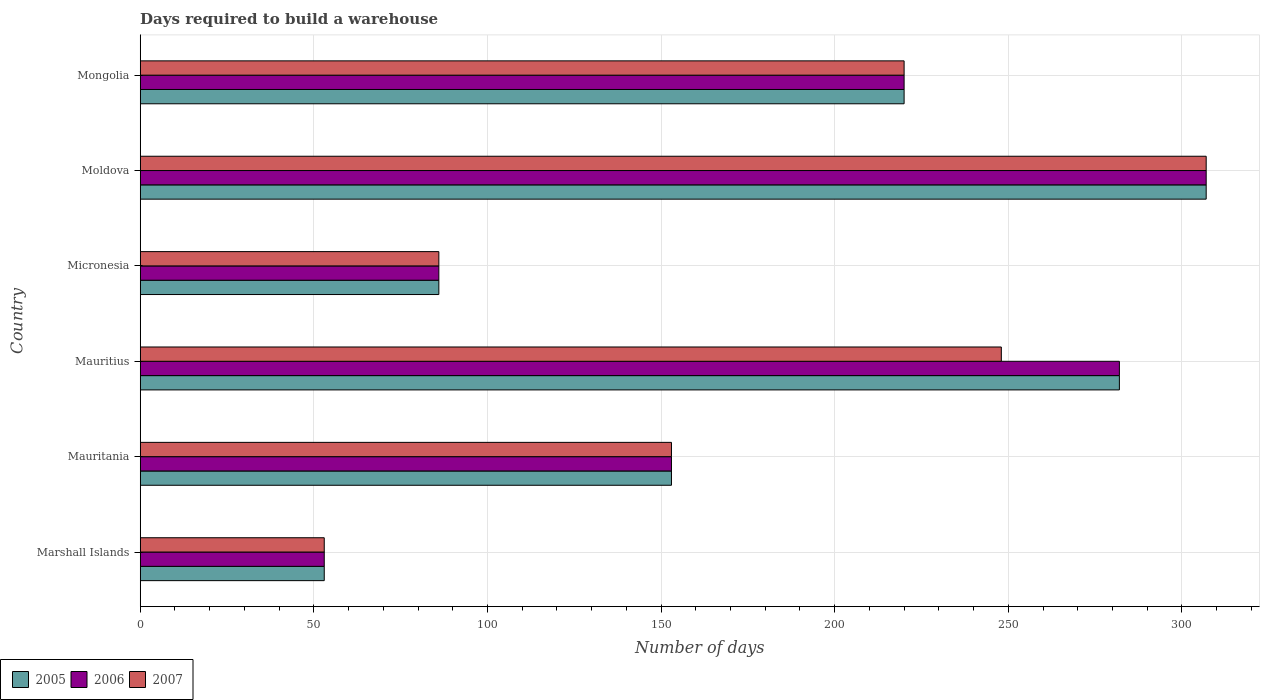How many bars are there on the 4th tick from the top?
Provide a succinct answer. 3. What is the label of the 1st group of bars from the top?
Give a very brief answer. Mongolia. In how many cases, is the number of bars for a given country not equal to the number of legend labels?
Keep it short and to the point. 0. What is the days required to build a warehouse in in 2007 in Mauritania?
Keep it short and to the point. 153. Across all countries, what is the maximum days required to build a warehouse in in 2006?
Provide a short and direct response. 307. In which country was the days required to build a warehouse in in 2006 maximum?
Provide a succinct answer. Moldova. In which country was the days required to build a warehouse in in 2006 minimum?
Keep it short and to the point. Marshall Islands. What is the total days required to build a warehouse in in 2007 in the graph?
Make the answer very short. 1067. What is the difference between the days required to build a warehouse in in 2006 in Mauritania and that in Moldova?
Provide a short and direct response. -154. What is the difference between the days required to build a warehouse in in 2005 in Marshall Islands and the days required to build a warehouse in in 2007 in Mongolia?
Your answer should be compact. -167. What is the average days required to build a warehouse in in 2005 per country?
Keep it short and to the point. 183.5. What is the difference between the days required to build a warehouse in in 2005 and days required to build a warehouse in in 2006 in Marshall Islands?
Make the answer very short. 0. What is the ratio of the days required to build a warehouse in in 2005 in Mauritius to that in Micronesia?
Offer a very short reply. 3.28. Is the days required to build a warehouse in in 2006 in Marshall Islands less than that in Mauritania?
Your response must be concise. Yes. Is the difference between the days required to build a warehouse in in 2005 in Micronesia and Mongolia greater than the difference between the days required to build a warehouse in in 2006 in Micronesia and Mongolia?
Your answer should be compact. No. What is the difference between the highest and the second highest days required to build a warehouse in in 2007?
Offer a very short reply. 59. What is the difference between the highest and the lowest days required to build a warehouse in in 2007?
Offer a terse response. 254. In how many countries, is the days required to build a warehouse in in 2006 greater than the average days required to build a warehouse in in 2006 taken over all countries?
Make the answer very short. 3. Is the sum of the days required to build a warehouse in in 2005 in Mauritania and Micronesia greater than the maximum days required to build a warehouse in in 2006 across all countries?
Make the answer very short. No. What does the 3rd bar from the bottom in Marshall Islands represents?
Your answer should be very brief. 2007. Is it the case that in every country, the sum of the days required to build a warehouse in in 2005 and days required to build a warehouse in in 2006 is greater than the days required to build a warehouse in in 2007?
Offer a very short reply. Yes. Are all the bars in the graph horizontal?
Provide a short and direct response. Yes. What is the difference between two consecutive major ticks on the X-axis?
Provide a short and direct response. 50. Are the values on the major ticks of X-axis written in scientific E-notation?
Give a very brief answer. No. Does the graph contain grids?
Keep it short and to the point. Yes. How many legend labels are there?
Provide a succinct answer. 3. What is the title of the graph?
Offer a terse response. Days required to build a warehouse. Does "1979" appear as one of the legend labels in the graph?
Give a very brief answer. No. What is the label or title of the X-axis?
Your answer should be compact. Number of days. What is the label or title of the Y-axis?
Provide a short and direct response. Country. What is the Number of days in 2006 in Marshall Islands?
Provide a short and direct response. 53. What is the Number of days in 2007 in Marshall Islands?
Provide a short and direct response. 53. What is the Number of days of 2005 in Mauritania?
Offer a terse response. 153. What is the Number of days of 2006 in Mauritania?
Ensure brevity in your answer.  153. What is the Number of days in 2007 in Mauritania?
Give a very brief answer. 153. What is the Number of days in 2005 in Mauritius?
Provide a succinct answer. 282. What is the Number of days in 2006 in Mauritius?
Your answer should be compact. 282. What is the Number of days in 2007 in Mauritius?
Your answer should be compact. 248. What is the Number of days in 2005 in Micronesia?
Offer a very short reply. 86. What is the Number of days of 2007 in Micronesia?
Your answer should be compact. 86. What is the Number of days in 2005 in Moldova?
Provide a succinct answer. 307. What is the Number of days in 2006 in Moldova?
Make the answer very short. 307. What is the Number of days in 2007 in Moldova?
Offer a terse response. 307. What is the Number of days of 2005 in Mongolia?
Your response must be concise. 220. What is the Number of days of 2006 in Mongolia?
Offer a very short reply. 220. What is the Number of days of 2007 in Mongolia?
Ensure brevity in your answer.  220. Across all countries, what is the maximum Number of days in 2005?
Your answer should be very brief. 307. Across all countries, what is the maximum Number of days in 2006?
Your response must be concise. 307. Across all countries, what is the maximum Number of days in 2007?
Give a very brief answer. 307. What is the total Number of days of 2005 in the graph?
Your answer should be very brief. 1101. What is the total Number of days of 2006 in the graph?
Ensure brevity in your answer.  1101. What is the total Number of days of 2007 in the graph?
Keep it short and to the point. 1067. What is the difference between the Number of days of 2005 in Marshall Islands and that in Mauritania?
Offer a very short reply. -100. What is the difference between the Number of days of 2006 in Marshall Islands and that in Mauritania?
Your answer should be very brief. -100. What is the difference between the Number of days of 2007 in Marshall Islands and that in Mauritania?
Keep it short and to the point. -100. What is the difference between the Number of days of 2005 in Marshall Islands and that in Mauritius?
Provide a succinct answer. -229. What is the difference between the Number of days in 2006 in Marshall Islands and that in Mauritius?
Make the answer very short. -229. What is the difference between the Number of days of 2007 in Marshall Islands and that in Mauritius?
Make the answer very short. -195. What is the difference between the Number of days in 2005 in Marshall Islands and that in Micronesia?
Your answer should be very brief. -33. What is the difference between the Number of days in 2006 in Marshall Islands and that in Micronesia?
Your answer should be compact. -33. What is the difference between the Number of days in 2007 in Marshall Islands and that in Micronesia?
Your answer should be compact. -33. What is the difference between the Number of days in 2005 in Marshall Islands and that in Moldova?
Offer a very short reply. -254. What is the difference between the Number of days of 2006 in Marshall Islands and that in Moldova?
Provide a short and direct response. -254. What is the difference between the Number of days of 2007 in Marshall Islands and that in Moldova?
Keep it short and to the point. -254. What is the difference between the Number of days of 2005 in Marshall Islands and that in Mongolia?
Offer a terse response. -167. What is the difference between the Number of days in 2006 in Marshall Islands and that in Mongolia?
Offer a very short reply. -167. What is the difference between the Number of days in 2007 in Marshall Islands and that in Mongolia?
Keep it short and to the point. -167. What is the difference between the Number of days of 2005 in Mauritania and that in Mauritius?
Your response must be concise. -129. What is the difference between the Number of days of 2006 in Mauritania and that in Mauritius?
Provide a short and direct response. -129. What is the difference between the Number of days in 2007 in Mauritania and that in Mauritius?
Offer a very short reply. -95. What is the difference between the Number of days in 2005 in Mauritania and that in Micronesia?
Offer a very short reply. 67. What is the difference between the Number of days in 2007 in Mauritania and that in Micronesia?
Offer a terse response. 67. What is the difference between the Number of days of 2005 in Mauritania and that in Moldova?
Your answer should be very brief. -154. What is the difference between the Number of days of 2006 in Mauritania and that in Moldova?
Ensure brevity in your answer.  -154. What is the difference between the Number of days of 2007 in Mauritania and that in Moldova?
Make the answer very short. -154. What is the difference between the Number of days in 2005 in Mauritania and that in Mongolia?
Keep it short and to the point. -67. What is the difference between the Number of days of 2006 in Mauritania and that in Mongolia?
Keep it short and to the point. -67. What is the difference between the Number of days of 2007 in Mauritania and that in Mongolia?
Your answer should be very brief. -67. What is the difference between the Number of days of 2005 in Mauritius and that in Micronesia?
Provide a succinct answer. 196. What is the difference between the Number of days in 2006 in Mauritius and that in Micronesia?
Provide a succinct answer. 196. What is the difference between the Number of days of 2007 in Mauritius and that in Micronesia?
Your answer should be compact. 162. What is the difference between the Number of days of 2007 in Mauritius and that in Moldova?
Offer a terse response. -59. What is the difference between the Number of days in 2007 in Mauritius and that in Mongolia?
Your answer should be very brief. 28. What is the difference between the Number of days of 2005 in Micronesia and that in Moldova?
Make the answer very short. -221. What is the difference between the Number of days of 2006 in Micronesia and that in Moldova?
Ensure brevity in your answer.  -221. What is the difference between the Number of days in 2007 in Micronesia and that in Moldova?
Your answer should be very brief. -221. What is the difference between the Number of days in 2005 in Micronesia and that in Mongolia?
Your response must be concise. -134. What is the difference between the Number of days of 2006 in Micronesia and that in Mongolia?
Offer a terse response. -134. What is the difference between the Number of days of 2007 in Micronesia and that in Mongolia?
Provide a short and direct response. -134. What is the difference between the Number of days in 2005 in Moldova and that in Mongolia?
Make the answer very short. 87. What is the difference between the Number of days in 2005 in Marshall Islands and the Number of days in 2006 in Mauritania?
Provide a short and direct response. -100. What is the difference between the Number of days in 2005 in Marshall Islands and the Number of days in 2007 in Mauritania?
Provide a succinct answer. -100. What is the difference between the Number of days of 2006 in Marshall Islands and the Number of days of 2007 in Mauritania?
Your response must be concise. -100. What is the difference between the Number of days in 2005 in Marshall Islands and the Number of days in 2006 in Mauritius?
Make the answer very short. -229. What is the difference between the Number of days in 2005 in Marshall Islands and the Number of days in 2007 in Mauritius?
Ensure brevity in your answer.  -195. What is the difference between the Number of days in 2006 in Marshall Islands and the Number of days in 2007 in Mauritius?
Keep it short and to the point. -195. What is the difference between the Number of days in 2005 in Marshall Islands and the Number of days in 2006 in Micronesia?
Provide a short and direct response. -33. What is the difference between the Number of days in 2005 in Marshall Islands and the Number of days in 2007 in Micronesia?
Ensure brevity in your answer.  -33. What is the difference between the Number of days of 2006 in Marshall Islands and the Number of days of 2007 in Micronesia?
Keep it short and to the point. -33. What is the difference between the Number of days in 2005 in Marshall Islands and the Number of days in 2006 in Moldova?
Provide a succinct answer. -254. What is the difference between the Number of days in 2005 in Marshall Islands and the Number of days in 2007 in Moldova?
Your answer should be very brief. -254. What is the difference between the Number of days of 2006 in Marshall Islands and the Number of days of 2007 in Moldova?
Provide a succinct answer. -254. What is the difference between the Number of days of 2005 in Marshall Islands and the Number of days of 2006 in Mongolia?
Your answer should be compact. -167. What is the difference between the Number of days in 2005 in Marshall Islands and the Number of days in 2007 in Mongolia?
Provide a short and direct response. -167. What is the difference between the Number of days in 2006 in Marshall Islands and the Number of days in 2007 in Mongolia?
Offer a terse response. -167. What is the difference between the Number of days in 2005 in Mauritania and the Number of days in 2006 in Mauritius?
Provide a short and direct response. -129. What is the difference between the Number of days in 2005 in Mauritania and the Number of days in 2007 in Mauritius?
Your answer should be compact. -95. What is the difference between the Number of days in 2006 in Mauritania and the Number of days in 2007 in Mauritius?
Give a very brief answer. -95. What is the difference between the Number of days of 2005 in Mauritania and the Number of days of 2006 in Micronesia?
Ensure brevity in your answer.  67. What is the difference between the Number of days in 2005 in Mauritania and the Number of days in 2007 in Micronesia?
Ensure brevity in your answer.  67. What is the difference between the Number of days of 2005 in Mauritania and the Number of days of 2006 in Moldova?
Your answer should be very brief. -154. What is the difference between the Number of days in 2005 in Mauritania and the Number of days in 2007 in Moldova?
Give a very brief answer. -154. What is the difference between the Number of days in 2006 in Mauritania and the Number of days in 2007 in Moldova?
Offer a terse response. -154. What is the difference between the Number of days of 2005 in Mauritania and the Number of days of 2006 in Mongolia?
Offer a very short reply. -67. What is the difference between the Number of days of 2005 in Mauritania and the Number of days of 2007 in Mongolia?
Make the answer very short. -67. What is the difference between the Number of days in 2006 in Mauritania and the Number of days in 2007 in Mongolia?
Provide a short and direct response. -67. What is the difference between the Number of days of 2005 in Mauritius and the Number of days of 2006 in Micronesia?
Keep it short and to the point. 196. What is the difference between the Number of days of 2005 in Mauritius and the Number of days of 2007 in Micronesia?
Keep it short and to the point. 196. What is the difference between the Number of days in 2006 in Mauritius and the Number of days in 2007 in Micronesia?
Provide a succinct answer. 196. What is the difference between the Number of days of 2005 in Mauritius and the Number of days of 2006 in Moldova?
Keep it short and to the point. -25. What is the difference between the Number of days of 2005 in Mauritius and the Number of days of 2007 in Moldova?
Ensure brevity in your answer.  -25. What is the difference between the Number of days of 2006 in Mauritius and the Number of days of 2007 in Moldova?
Your answer should be very brief. -25. What is the difference between the Number of days in 2006 in Mauritius and the Number of days in 2007 in Mongolia?
Give a very brief answer. 62. What is the difference between the Number of days in 2005 in Micronesia and the Number of days in 2006 in Moldova?
Make the answer very short. -221. What is the difference between the Number of days in 2005 in Micronesia and the Number of days in 2007 in Moldova?
Provide a succinct answer. -221. What is the difference between the Number of days of 2006 in Micronesia and the Number of days of 2007 in Moldova?
Provide a succinct answer. -221. What is the difference between the Number of days in 2005 in Micronesia and the Number of days in 2006 in Mongolia?
Your response must be concise. -134. What is the difference between the Number of days in 2005 in Micronesia and the Number of days in 2007 in Mongolia?
Your response must be concise. -134. What is the difference between the Number of days of 2006 in Micronesia and the Number of days of 2007 in Mongolia?
Provide a short and direct response. -134. What is the difference between the Number of days in 2006 in Moldova and the Number of days in 2007 in Mongolia?
Provide a succinct answer. 87. What is the average Number of days in 2005 per country?
Your response must be concise. 183.5. What is the average Number of days of 2006 per country?
Offer a terse response. 183.5. What is the average Number of days in 2007 per country?
Your answer should be very brief. 177.83. What is the difference between the Number of days in 2005 and Number of days in 2006 in Marshall Islands?
Your response must be concise. 0. What is the difference between the Number of days in 2005 and Number of days in 2007 in Micronesia?
Offer a very short reply. 0. What is the ratio of the Number of days of 2005 in Marshall Islands to that in Mauritania?
Give a very brief answer. 0.35. What is the ratio of the Number of days of 2006 in Marshall Islands to that in Mauritania?
Provide a short and direct response. 0.35. What is the ratio of the Number of days in 2007 in Marshall Islands to that in Mauritania?
Your response must be concise. 0.35. What is the ratio of the Number of days in 2005 in Marshall Islands to that in Mauritius?
Offer a very short reply. 0.19. What is the ratio of the Number of days in 2006 in Marshall Islands to that in Mauritius?
Your response must be concise. 0.19. What is the ratio of the Number of days in 2007 in Marshall Islands to that in Mauritius?
Provide a short and direct response. 0.21. What is the ratio of the Number of days in 2005 in Marshall Islands to that in Micronesia?
Offer a very short reply. 0.62. What is the ratio of the Number of days of 2006 in Marshall Islands to that in Micronesia?
Provide a short and direct response. 0.62. What is the ratio of the Number of days of 2007 in Marshall Islands to that in Micronesia?
Ensure brevity in your answer.  0.62. What is the ratio of the Number of days of 2005 in Marshall Islands to that in Moldova?
Your answer should be compact. 0.17. What is the ratio of the Number of days of 2006 in Marshall Islands to that in Moldova?
Keep it short and to the point. 0.17. What is the ratio of the Number of days of 2007 in Marshall Islands to that in Moldova?
Ensure brevity in your answer.  0.17. What is the ratio of the Number of days in 2005 in Marshall Islands to that in Mongolia?
Provide a short and direct response. 0.24. What is the ratio of the Number of days in 2006 in Marshall Islands to that in Mongolia?
Keep it short and to the point. 0.24. What is the ratio of the Number of days in 2007 in Marshall Islands to that in Mongolia?
Give a very brief answer. 0.24. What is the ratio of the Number of days of 2005 in Mauritania to that in Mauritius?
Offer a very short reply. 0.54. What is the ratio of the Number of days of 2006 in Mauritania to that in Mauritius?
Provide a succinct answer. 0.54. What is the ratio of the Number of days of 2007 in Mauritania to that in Mauritius?
Your response must be concise. 0.62. What is the ratio of the Number of days in 2005 in Mauritania to that in Micronesia?
Ensure brevity in your answer.  1.78. What is the ratio of the Number of days in 2006 in Mauritania to that in Micronesia?
Your answer should be very brief. 1.78. What is the ratio of the Number of days of 2007 in Mauritania to that in Micronesia?
Keep it short and to the point. 1.78. What is the ratio of the Number of days of 2005 in Mauritania to that in Moldova?
Your answer should be very brief. 0.5. What is the ratio of the Number of days of 2006 in Mauritania to that in Moldova?
Ensure brevity in your answer.  0.5. What is the ratio of the Number of days in 2007 in Mauritania to that in Moldova?
Keep it short and to the point. 0.5. What is the ratio of the Number of days in 2005 in Mauritania to that in Mongolia?
Offer a very short reply. 0.7. What is the ratio of the Number of days in 2006 in Mauritania to that in Mongolia?
Provide a short and direct response. 0.7. What is the ratio of the Number of days in 2007 in Mauritania to that in Mongolia?
Offer a very short reply. 0.7. What is the ratio of the Number of days of 2005 in Mauritius to that in Micronesia?
Make the answer very short. 3.28. What is the ratio of the Number of days in 2006 in Mauritius to that in Micronesia?
Provide a succinct answer. 3.28. What is the ratio of the Number of days in 2007 in Mauritius to that in Micronesia?
Your answer should be compact. 2.88. What is the ratio of the Number of days in 2005 in Mauritius to that in Moldova?
Ensure brevity in your answer.  0.92. What is the ratio of the Number of days in 2006 in Mauritius to that in Moldova?
Offer a terse response. 0.92. What is the ratio of the Number of days in 2007 in Mauritius to that in Moldova?
Your answer should be very brief. 0.81. What is the ratio of the Number of days of 2005 in Mauritius to that in Mongolia?
Ensure brevity in your answer.  1.28. What is the ratio of the Number of days in 2006 in Mauritius to that in Mongolia?
Offer a terse response. 1.28. What is the ratio of the Number of days of 2007 in Mauritius to that in Mongolia?
Offer a very short reply. 1.13. What is the ratio of the Number of days in 2005 in Micronesia to that in Moldova?
Keep it short and to the point. 0.28. What is the ratio of the Number of days of 2006 in Micronesia to that in Moldova?
Keep it short and to the point. 0.28. What is the ratio of the Number of days in 2007 in Micronesia to that in Moldova?
Offer a very short reply. 0.28. What is the ratio of the Number of days in 2005 in Micronesia to that in Mongolia?
Your answer should be very brief. 0.39. What is the ratio of the Number of days in 2006 in Micronesia to that in Mongolia?
Your answer should be very brief. 0.39. What is the ratio of the Number of days in 2007 in Micronesia to that in Mongolia?
Your answer should be compact. 0.39. What is the ratio of the Number of days of 2005 in Moldova to that in Mongolia?
Your answer should be very brief. 1.4. What is the ratio of the Number of days of 2006 in Moldova to that in Mongolia?
Provide a short and direct response. 1.4. What is the ratio of the Number of days of 2007 in Moldova to that in Mongolia?
Give a very brief answer. 1.4. What is the difference between the highest and the second highest Number of days of 2005?
Your answer should be compact. 25. What is the difference between the highest and the second highest Number of days of 2006?
Offer a very short reply. 25. What is the difference between the highest and the second highest Number of days of 2007?
Give a very brief answer. 59. What is the difference between the highest and the lowest Number of days in 2005?
Keep it short and to the point. 254. What is the difference between the highest and the lowest Number of days of 2006?
Provide a short and direct response. 254. What is the difference between the highest and the lowest Number of days in 2007?
Your response must be concise. 254. 